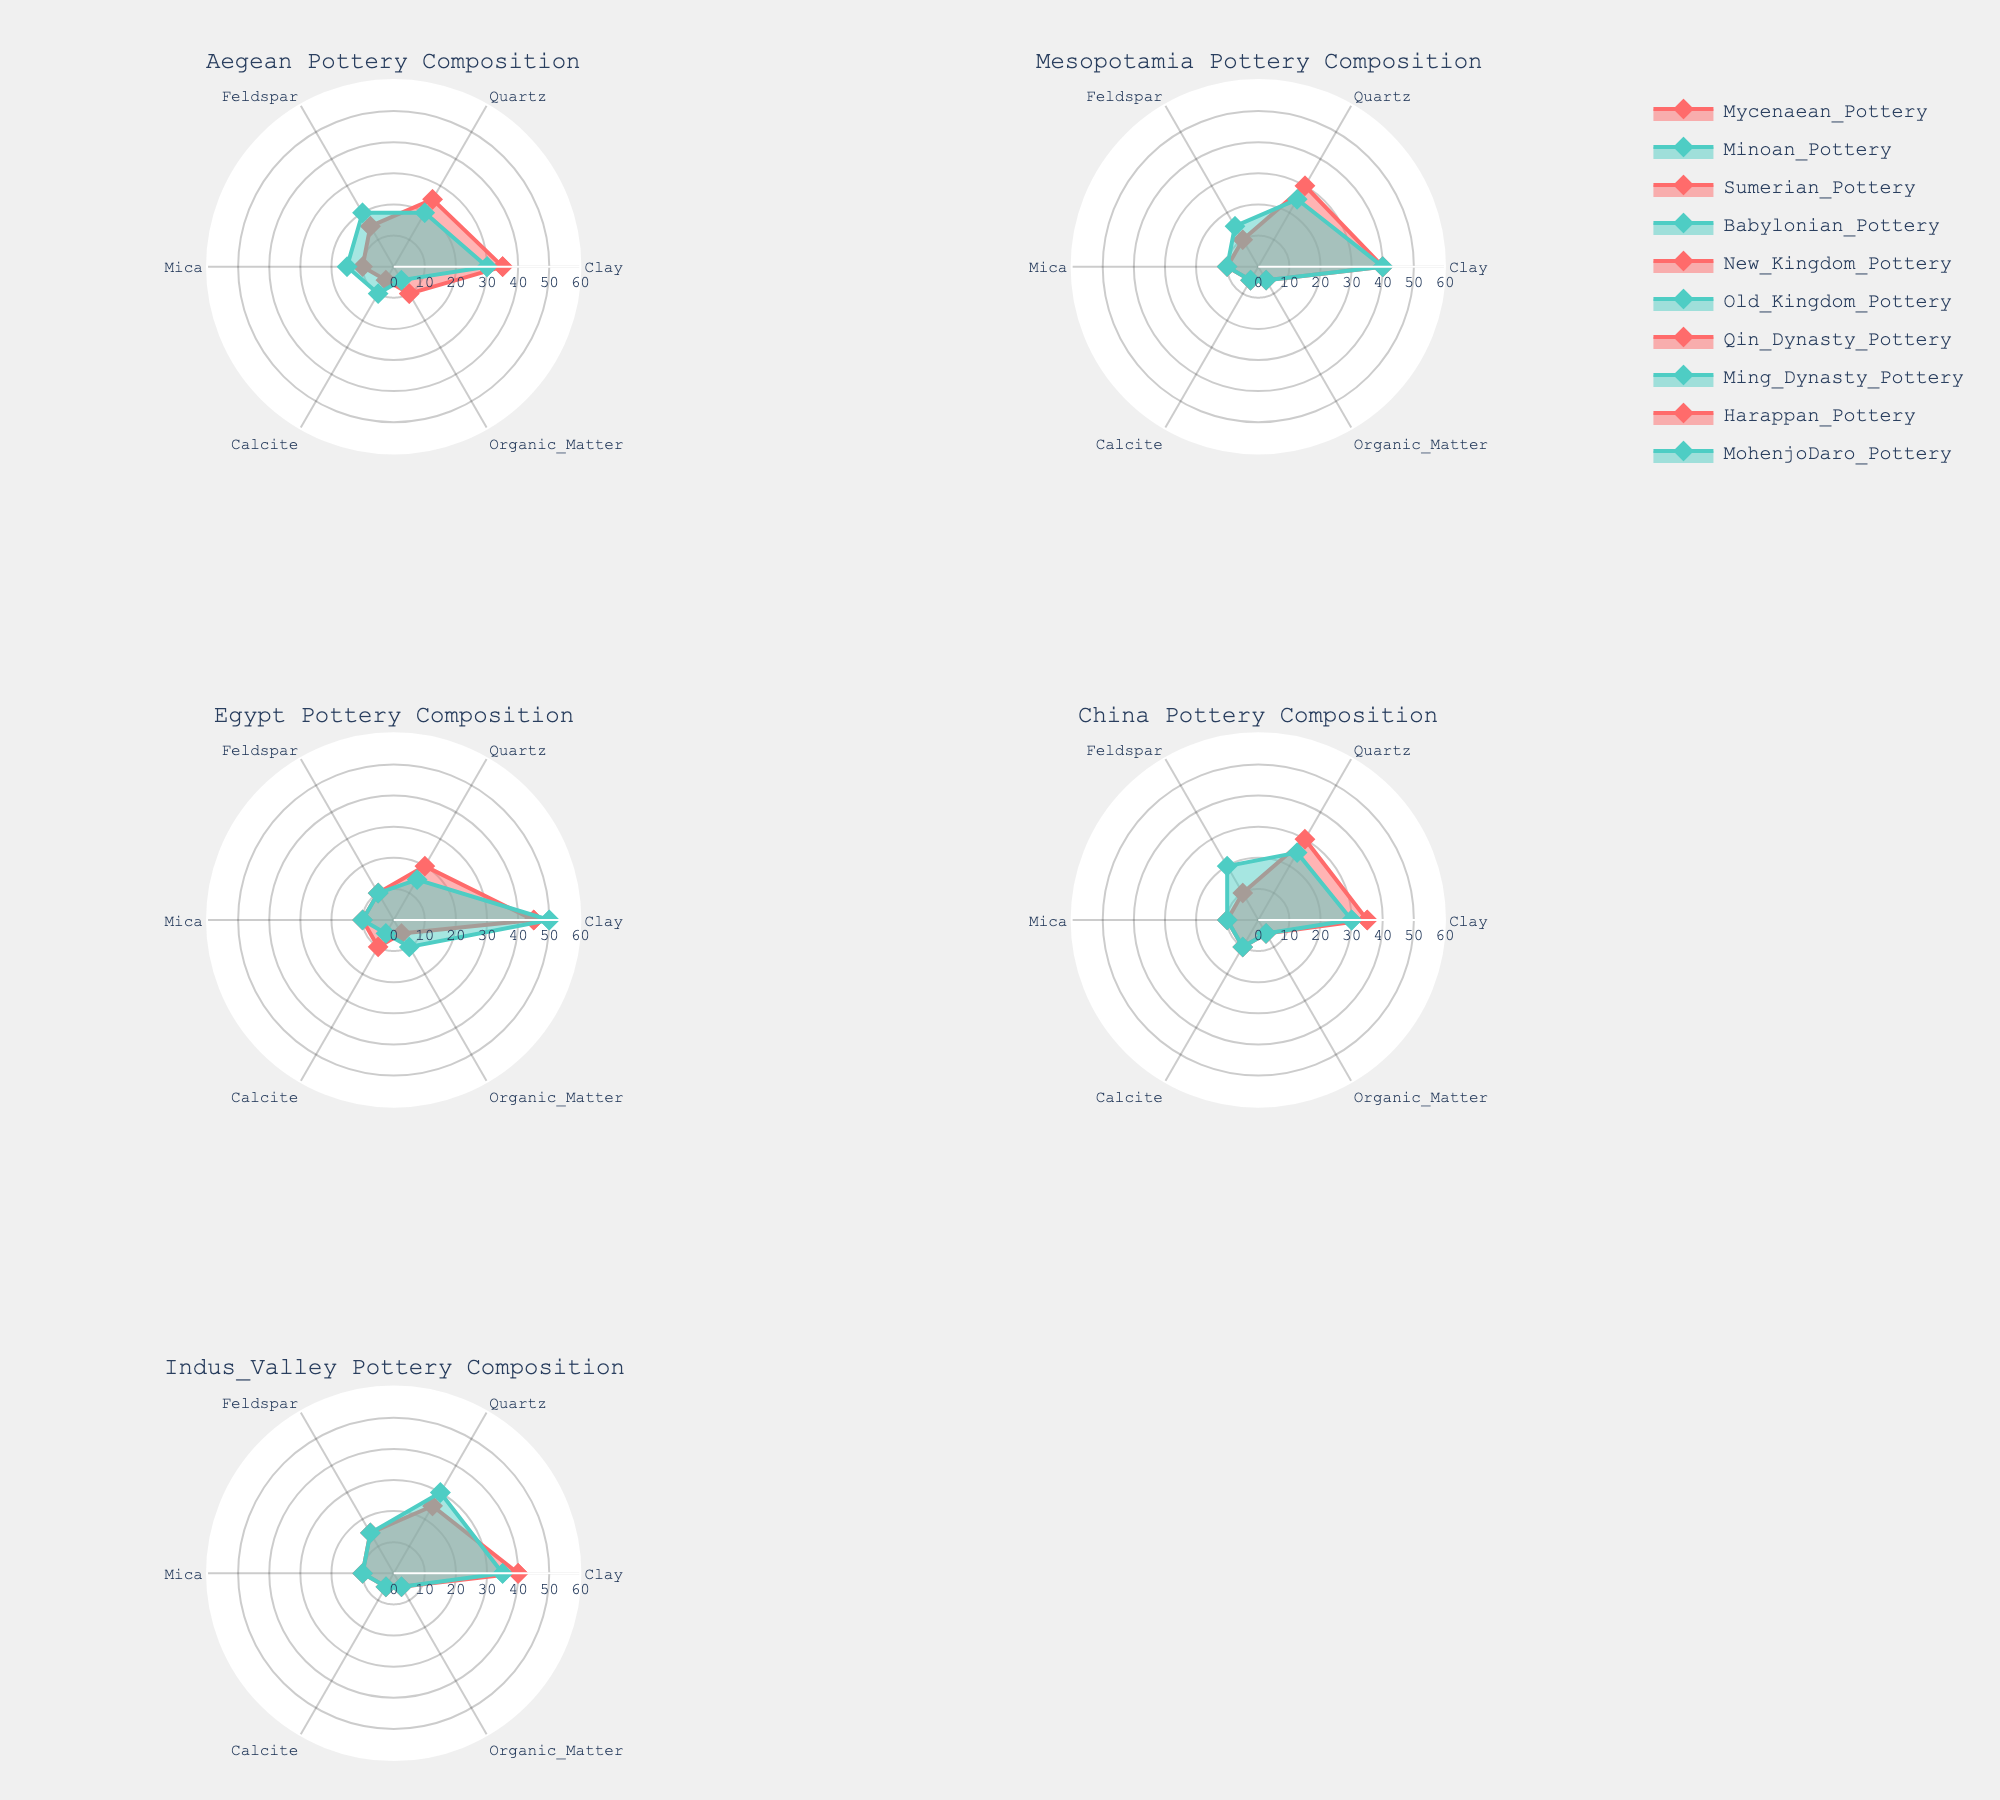What's the main title of the figure? The main title of the figure is presented at the top and serves to summarize the content displayed in the radar charts, which is the "Fragment composition of ancient pottery with analysis of regional variations".
Answer: Fragment composition of ancient pottery with analysis of regional variations How many regions are represented in the subplot of radar charts? You need to count the number of unique radar charts, each representing a different region. There are six radar charts displayed.
Answer: Six Which region has the highest clay content in any of its pottery types? Look for the highest value on the clay axis for each region. The New Kingdom pottery in Egypt has the highest clay content at 45%.
Answer: Egypt What's the average quartz content in Mesopotamian pottery? Sum the quartz content of the Sumerian and Babylonian pottery (30 + 25 = 55), then divide by the number of pottery types (2).
Answer: 27.5% In the Aegean region, which pottery type has a greater amount of mica? Compare the mica content in Mycenaean (10%) and Minoan (15%) pottery. The Minoan pottery has a greater amount.
Answer: Minoan pottery Which pottery type has the highest organic matter content in China? Look for the highest organic matter value in the Qin Dynasty (5%) and Ming Dynasty (5%) pottery. Both have the same value.
Answer: Qin Dynasty pottery, Ming Dynasty pottery Which regions have pottery types with identical mica content of 10%? Identify regions where any pottery has a mica content of 10%. The regions are Aegean, Mesopotamia, Egypt, China, and Indus Valley.
Answer: Aegean, Mesopotamia, Egypt, China, Indus Valley In the Indus Valley region, what is the average feldspar content across both pottery types? Sum the feldspar content of Harappan (15%) and MohenjoDaro (15%) pottery, then divide by the number of pottery types (2).
Answer: 15% Does the Sumerian pottery contain more calcite or more clay? Compare the calcite (5%) and clay (40%) content of Sumerian pottery. It contains more clay.
Answer: More clay 